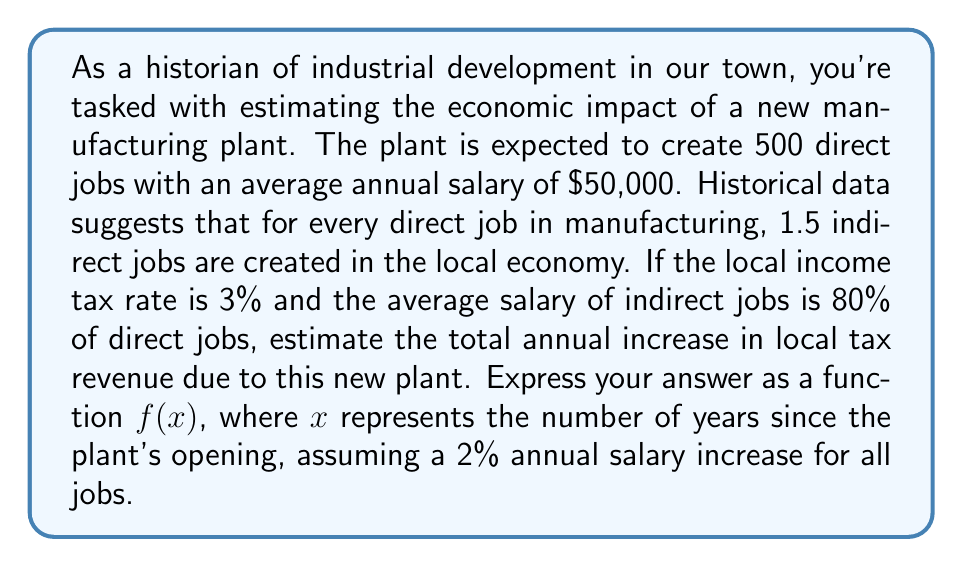What is the answer to this math problem? Let's break this down step-by-step:

1) First, let's calculate the number of indirect jobs:
   Indirect jobs = 500 * 1.5 = 750 jobs

2) Total new jobs = Direct jobs + Indirect jobs
                  = 500 + 750 = 1,250 jobs

3) Initial annual salaries:
   Direct jobs: $50,000
   Indirect jobs: $50,000 * 0.80 = $40,000

4) Initial total annual salaries:
   Direct: 500 * $50,000 = $25,000,000
   Indirect: 750 * $40,000 = $30,000,000
   Total: $55,000,000

5) Initial annual tax revenue:
   $55,000,000 * 0.03 = $1,650,000

6) To account for the 2% annual salary increase, we can use the compound interest formula:
   $A = P(1 + r)^n$
   Where A is the amount after n years, P is the principal amount, r is the annual rate, and n is the number of years.

7) Our function $f(x)$ will be:

   $$f(x) = [25,000,000 * (1.02)^x + 30,000,000 * (1.02)^x] * 0.03$$

8) Simplifying:

   $$f(x) = 1,650,000 * (1.02)^x$$

This function will give us the total annual tax revenue x years after the plant opens, accounting for the 2% annual salary increase.
Answer: $$f(x) = 1,650,000 * (1.02)^x$$ 